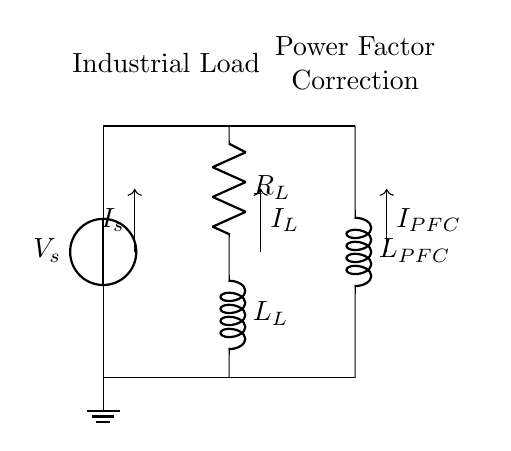What is the resistance value in the circuit? The circuit diagram indicates a resistor labeled as "R_L," but the value is not explicitly provided here. It is assumed to be available in specific design calculations.
Answer: R_L What component provides power factor correction? The component identified in the circuit diagram for power factor correction is labeled as "L_PFC," which is an inductor. This indicates its role in improving the power factor of the circuit.
Answer: L_PFC How do the currents in the circuit flow? The circuit diagram has arrows showing current directions: "I_s" flows into the load, "I_L" flows through the load resistor and inductor, while "I_PFC" flows through the power factor correction inductor. Tracking these arrows shows the intended flow direction.
Answer: I_s, I_L, I_PFC What is the purpose of using an inductor in this circuit? The inductor labeled as "L_PFC" is used for power factor correction in industrial facilities to minimize reactive power and improve efficiency. This is essential to reduce energy costs associated with poor power factor.
Answer: Minimize reactive power How many inductors are present in the circuit? The circuit contains two inductors, one as part of the load ("L_L") and another for power factor correction ("L_PFC"). Counting the inductor symbols in the diagram confirms this.
Answer: 2 What is the primary load type represented in this circuit? The load is represented by the combination of "R_L" and "L_L," indicating it is a resistive-inductive load. This combination is typical for industrial facilities where different loads exist.
Answer: Resistive-inductive load 